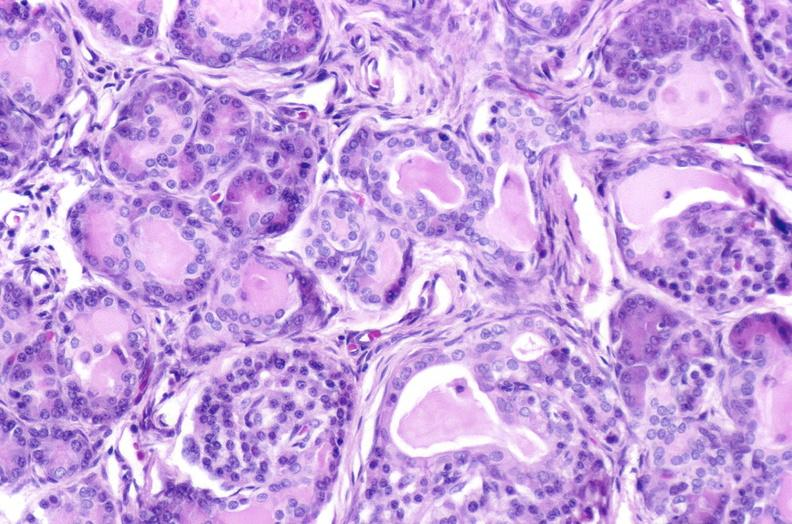s crookes cells present?
Answer the question using a single word or phrase. No 